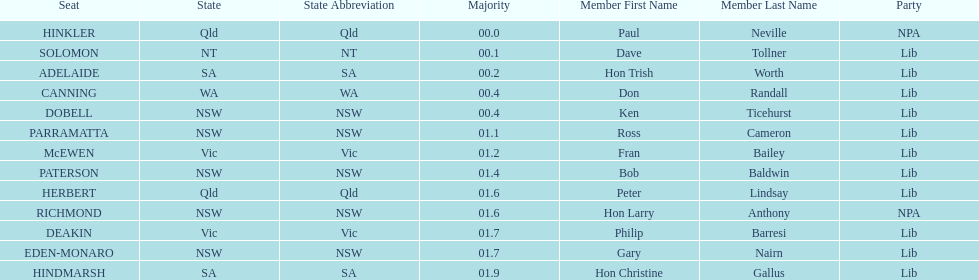How many members in total? 13. 